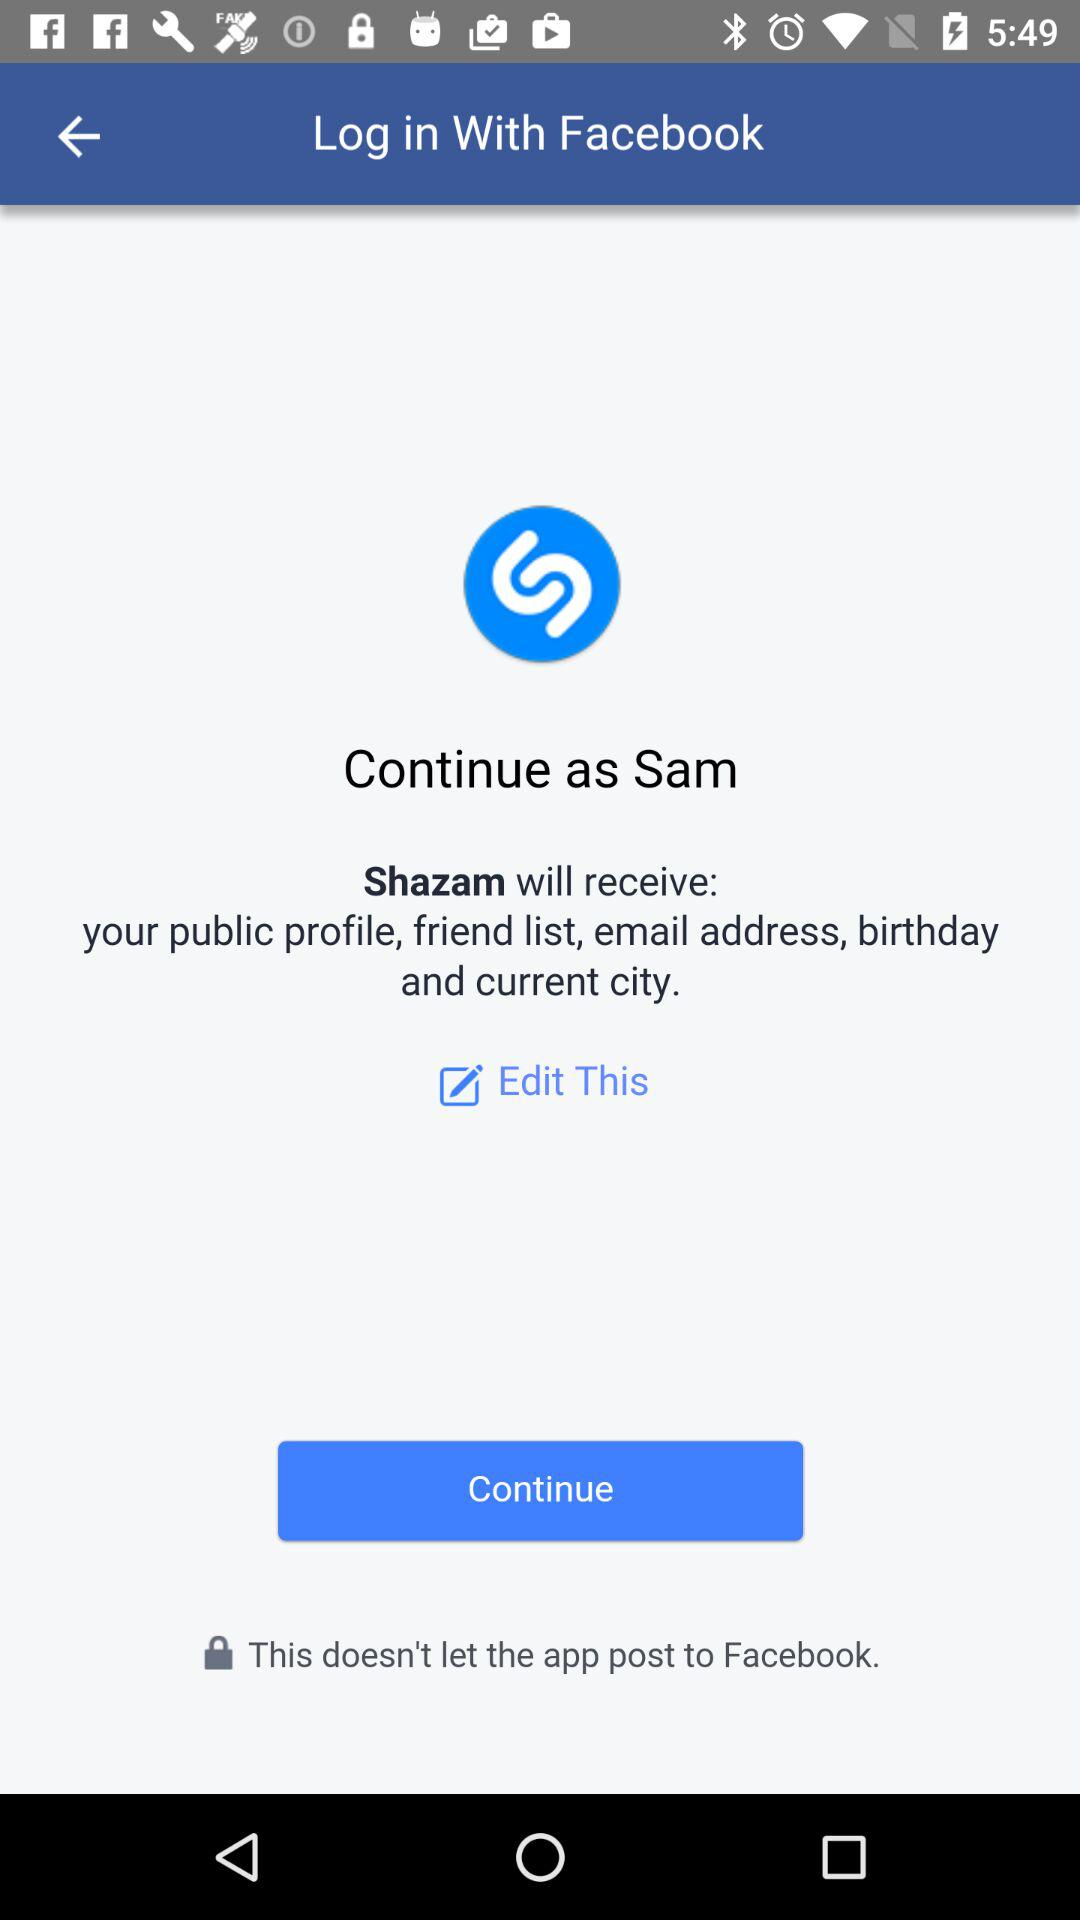Who will receive the details? The details will be received by "Shazam". 